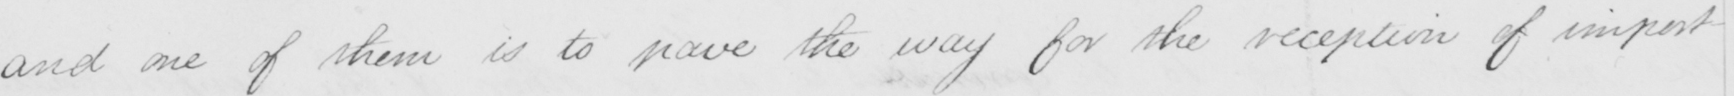Please transcribe the handwritten text in this image. and one of them is to pave the way for the reception of important 